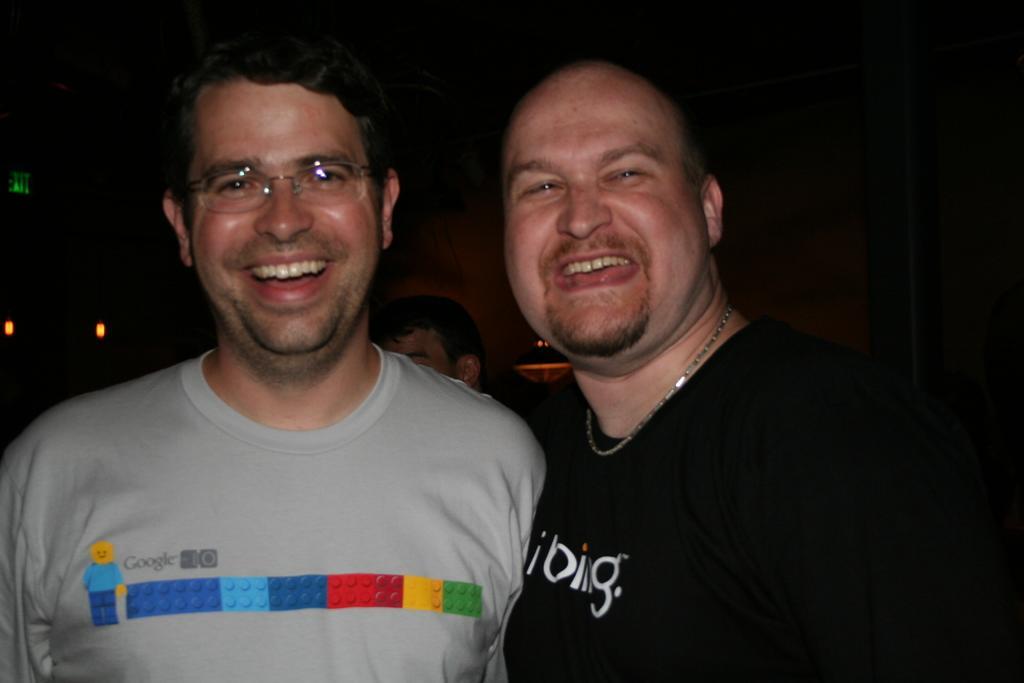In one or two sentences, can you explain what this image depicts? This image is taken indoors. In this image the background is dark and there is a person. In the middle of the image two men are standing and they are with smiling faces. 